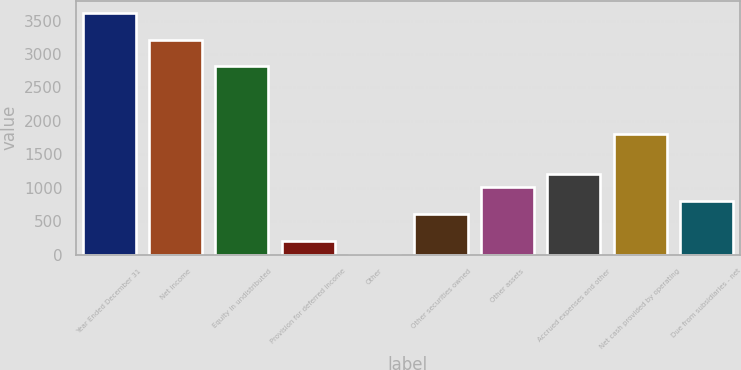<chart> <loc_0><loc_0><loc_500><loc_500><bar_chart><fcel>Year Ended December 31<fcel>Net income<fcel>Equity in undistributed<fcel>Provision for deferred income<fcel>Other<fcel>Other securities owned<fcel>Other assets<fcel>Accrued expenses and other<fcel>Net cash provided by operating<fcel>Due from subsidiaries - net<nl><fcel>3619<fcel>3217<fcel>2815<fcel>202<fcel>1<fcel>604<fcel>1006<fcel>1207<fcel>1810<fcel>805<nl></chart> 